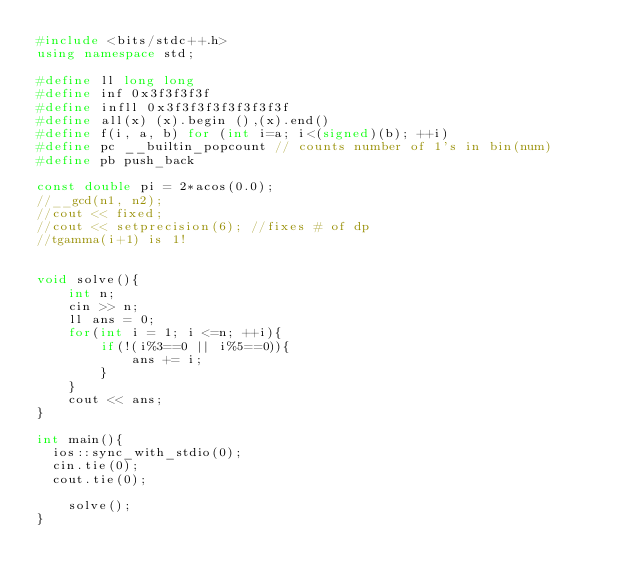Convert code to text. <code><loc_0><loc_0><loc_500><loc_500><_C++_>#include <bits/stdc++.h>
using namespace std;

#define ll long long 
#define inf 0x3f3f3f3f
#define infll 0x3f3f3f3f3f3f3f3f
#define all(x) (x).begin (),(x).end()
#define f(i, a, b) for (int i=a; i<(signed)(b); ++i)
#define pc __builtin_popcount // counts number of 1's in bin(num)
#define pb push_back

const double pi = 2*acos(0.0);
//__gcd(n1, n2);
//cout << fixed;
//cout << setprecision(6); //fixes # of dp
//tgamma(i+1) is 1!


void solve(){
    int n;
    cin >> n;
    ll ans = 0;
    for(int i = 1; i <=n; ++i){
        if(!(i%3==0 || i%5==0)){
            ans += i;
        }
    }
    cout << ans;
}

int main(){
	ios::sync_with_stdio(0);
	cin.tie(0);
	cout.tie(0);

    solve();
}






</code> 